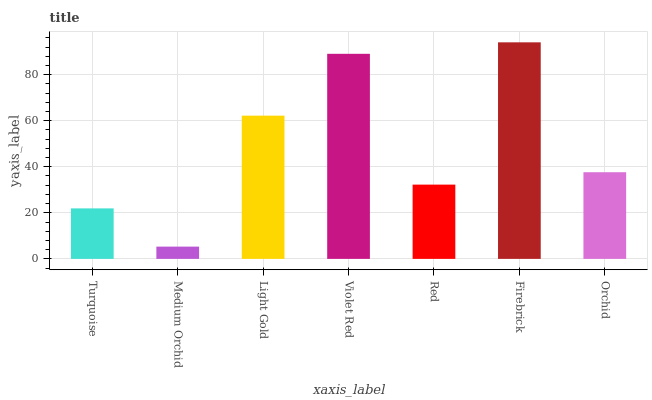Is Medium Orchid the minimum?
Answer yes or no. Yes. Is Firebrick the maximum?
Answer yes or no. Yes. Is Light Gold the minimum?
Answer yes or no. No. Is Light Gold the maximum?
Answer yes or no. No. Is Light Gold greater than Medium Orchid?
Answer yes or no. Yes. Is Medium Orchid less than Light Gold?
Answer yes or no. Yes. Is Medium Orchid greater than Light Gold?
Answer yes or no. No. Is Light Gold less than Medium Orchid?
Answer yes or no. No. Is Orchid the high median?
Answer yes or no. Yes. Is Orchid the low median?
Answer yes or no. Yes. Is Turquoise the high median?
Answer yes or no. No. Is Light Gold the low median?
Answer yes or no. No. 